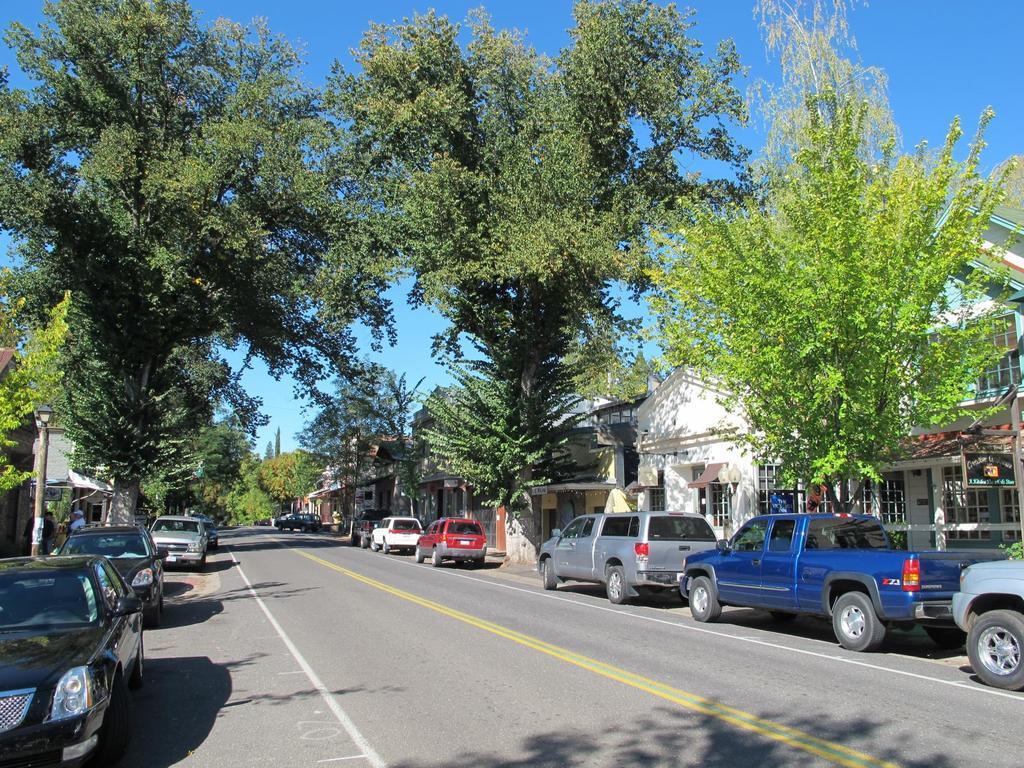Describe this image in one or two sentences. In this picture we can see sky. On either side of the road we can see trees and houses. These are cars on the road. 